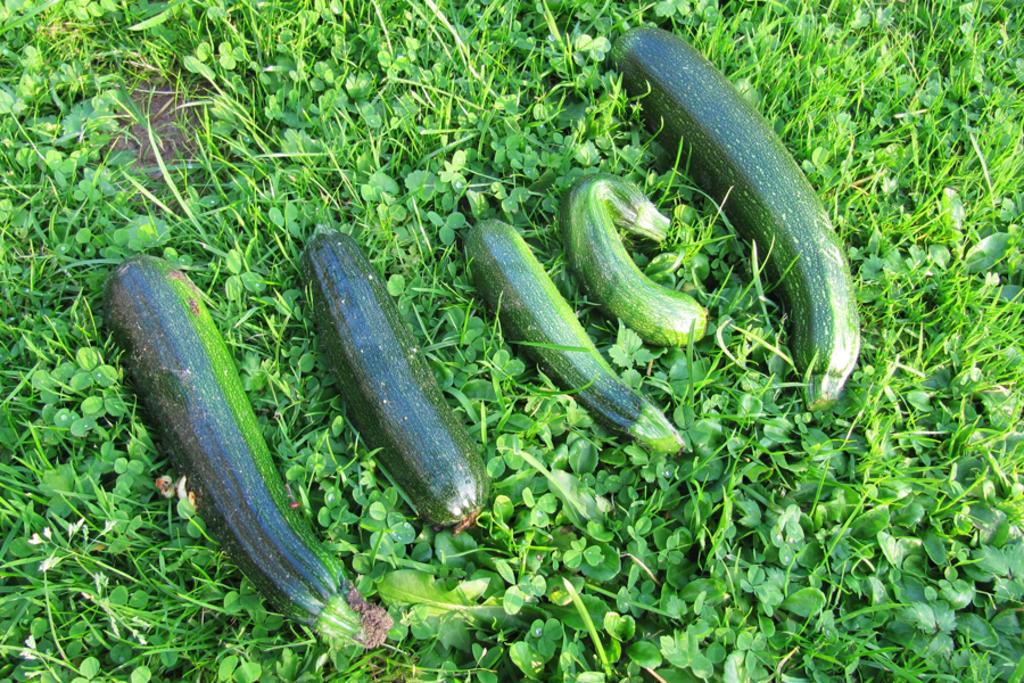What type of vegetables are arranged in the image? There are green color vegetables arranged on the grass. Where are the vegetables located in the image? The vegetables are on the ground. What can be seen in the background of the image? There are green color plants in the background. What month is the queen celebrating her birthday in the image? There is no queen or birthday celebration present in the image. 